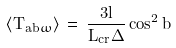<formula> <loc_0><loc_0><loc_500><loc_500>\langle T _ { a b \omega } \rangle \, = \, \frac { 3 l } { L _ { c r } \Delta } \cos ^ { 2 } b</formula> 